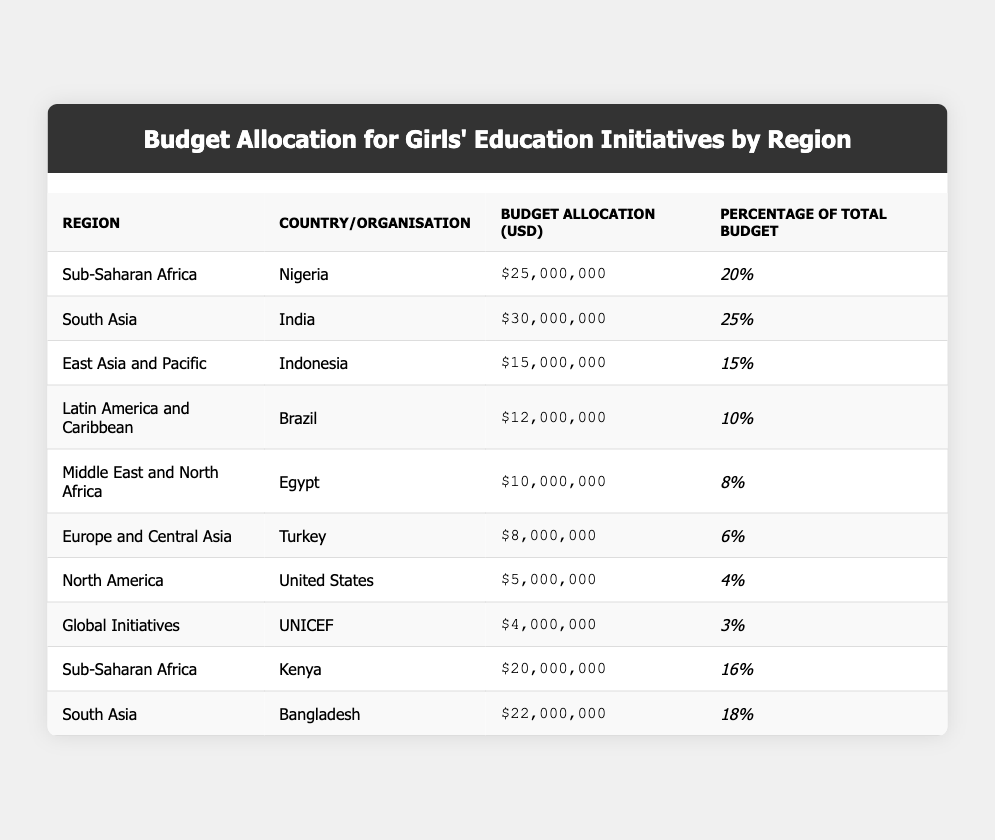What is the total budget allocation for girls' education initiatives in Sub-Saharan Africa? The table shows two allocations for Sub-Saharan Africa: Nigeria ($25,000,000) and Kenya ($20,000,000). Adding these together, we get 25,000,000 + 20,000,000 = 45,000,000.
Answer: 45,000,000 Which country has the highest budget allocation for girls' education? According to the table, India has the highest budget allocation at $30,000,000.
Answer: India What percentage of the total budget is allocated to global initiatives? The table indicates that UNICEF, under Global Initiatives, has a budget allocation of $4,000,000, which is 3% of the total budget.
Answer: 3% Is the budget allocation for Egypt greater than the budget for Brazil? The table shows Egypt's allocation at $10,000,000 and Brazil's at $12,000,000. Since 10,000,000 is less than 12,000,000, the statement is false.
Answer: No What is the combined budget allocation for South Asia? South Asia consists of two countries: India ($30,000,000) and Bangladesh ($22,000,000). Summing these gives 30,000,000 + 22,000,000 = 52,000,000.
Answer: 52,000,000 Which region has the least budget allocation for girls' education? The table lists North America with a budget allocation of $5,000,000, which is lower than all other regions listed.
Answer: North America If we consider the countries from Sub-Saharan Africa, what is the average budget allocation? The countries listed under Sub-Saharan Africa are Nigeria ($25,000,000) and Kenya ($20,000,000). To find the average, we add these amounts (25,000,000 + 20,000,000 = 45,000,000) and divide by the number of countries (2). Thus, 45,000,000 / 2 = 22,500,000.
Answer: 22,500,000 How much funding is allocated to Turkey compared to the total education budget? Turkey's allocation is $8,000,000. To find how much this represents against the total budget, we consider Turkey's allocation as a part of the overall budget but would need the total budget amount for precise percentage calculations. Without that, we can only state Turkey's specific allocation.
Answer: $8,000,000 Does the budget for girls' education in Kenya exceed the combined budget of Brazil and Egypt? The budget for Kenya is $20,000,000, Brazil is $12,000,000, and Egypt is $10,000,000. The combined budget for Brazil and Egypt is 12,000,000 + 10,000,000 = 22,000,000. Since 20,000,000 is less than 22,000,000, the statement is false.
Answer: No What is the total budget allocation for South Asia divided by the total budget allocation for Europe and Central Asia? The total budget for South Asia (India: $30,000,000; Bangladesh: $22,000,000) is 52,000,000, while Europe and Central Asia (Turkey: $8,000,000) is just $8,000,000. Dividing these gives us 52,000,000 / 8,000,000 = 6.5.
Answer: 6.5 